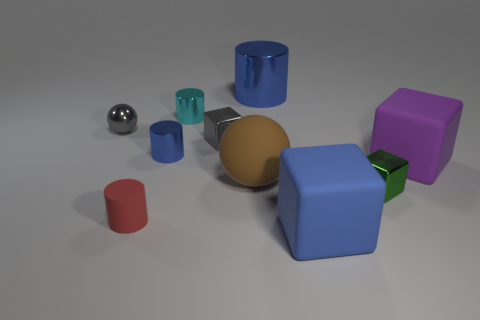How many small things are yellow shiny objects or green objects?
Offer a terse response. 1. Are there any cyan cylinders?
Provide a succinct answer. Yes. What size is the cyan cylinder that is made of the same material as the tiny gray sphere?
Your answer should be compact. Small. Do the big blue cylinder and the big purple object have the same material?
Your answer should be very brief. No. How many other things are made of the same material as the big brown object?
Keep it short and to the point. 3. What number of cubes are on the right side of the blue matte thing and in front of the tiny green object?
Make the answer very short. 0. The shiny ball has what color?
Keep it short and to the point. Gray. What material is the green thing that is the same shape as the blue matte thing?
Keep it short and to the point. Metal. Is there any other thing that has the same material as the purple thing?
Offer a very short reply. Yes. Does the small shiny ball have the same color as the tiny matte cylinder?
Give a very brief answer. No. 